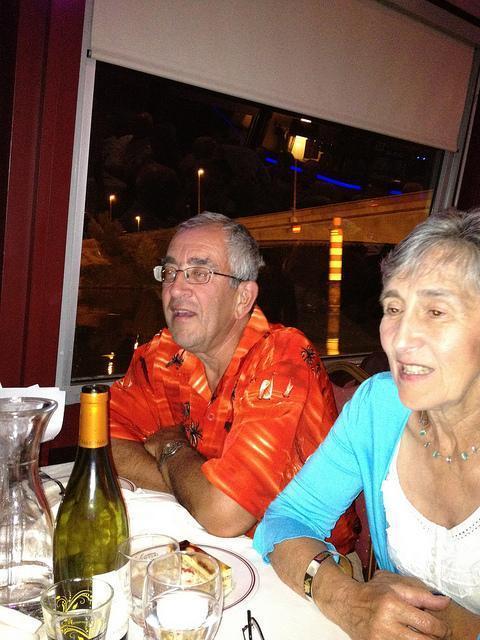How many wine glasses can you see?
Give a very brief answer. 2. How many boats are there?
Give a very brief answer. 1. How many dining tables can be seen?
Give a very brief answer. 1. How many people are there?
Give a very brief answer. 2. 